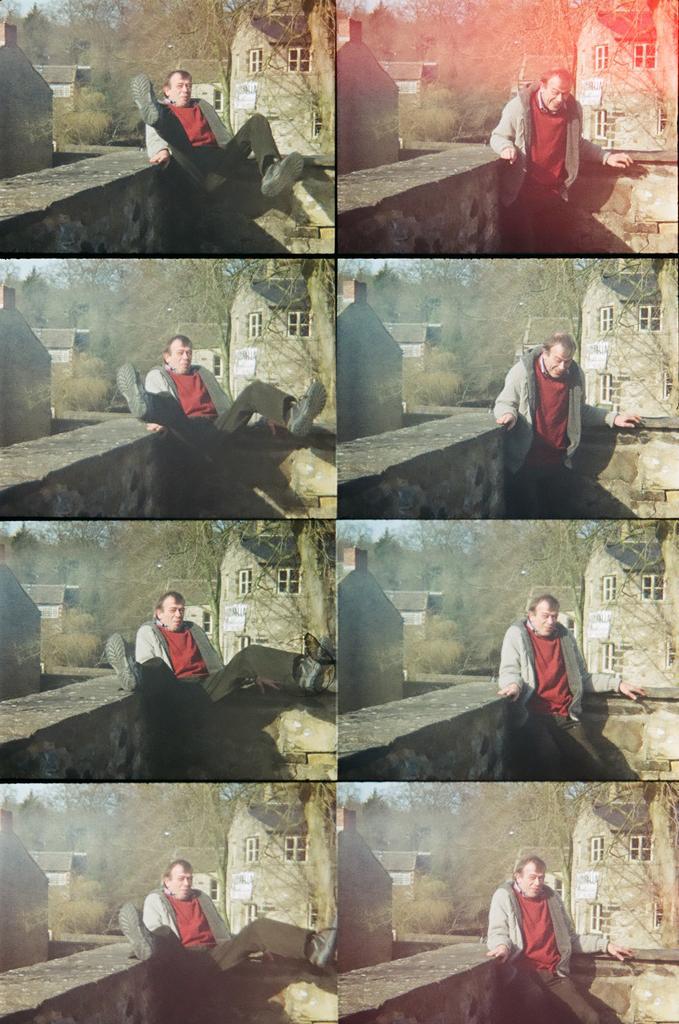How would you summarize this image in a sentence or two? There is a collage image of different pictures of a same person. In the first four pictures, we can see person jumping above the ground. In remaining pictures we can see person standing in front of the wall. 